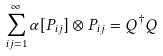Convert formula to latex. <formula><loc_0><loc_0><loc_500><loc_500>\sum _ { i j = 1 } ^ { \infty } \alpha [ P _ { i j } ] \otimes P _ { i j } = Q ^ { \dagger } Q</formula> 